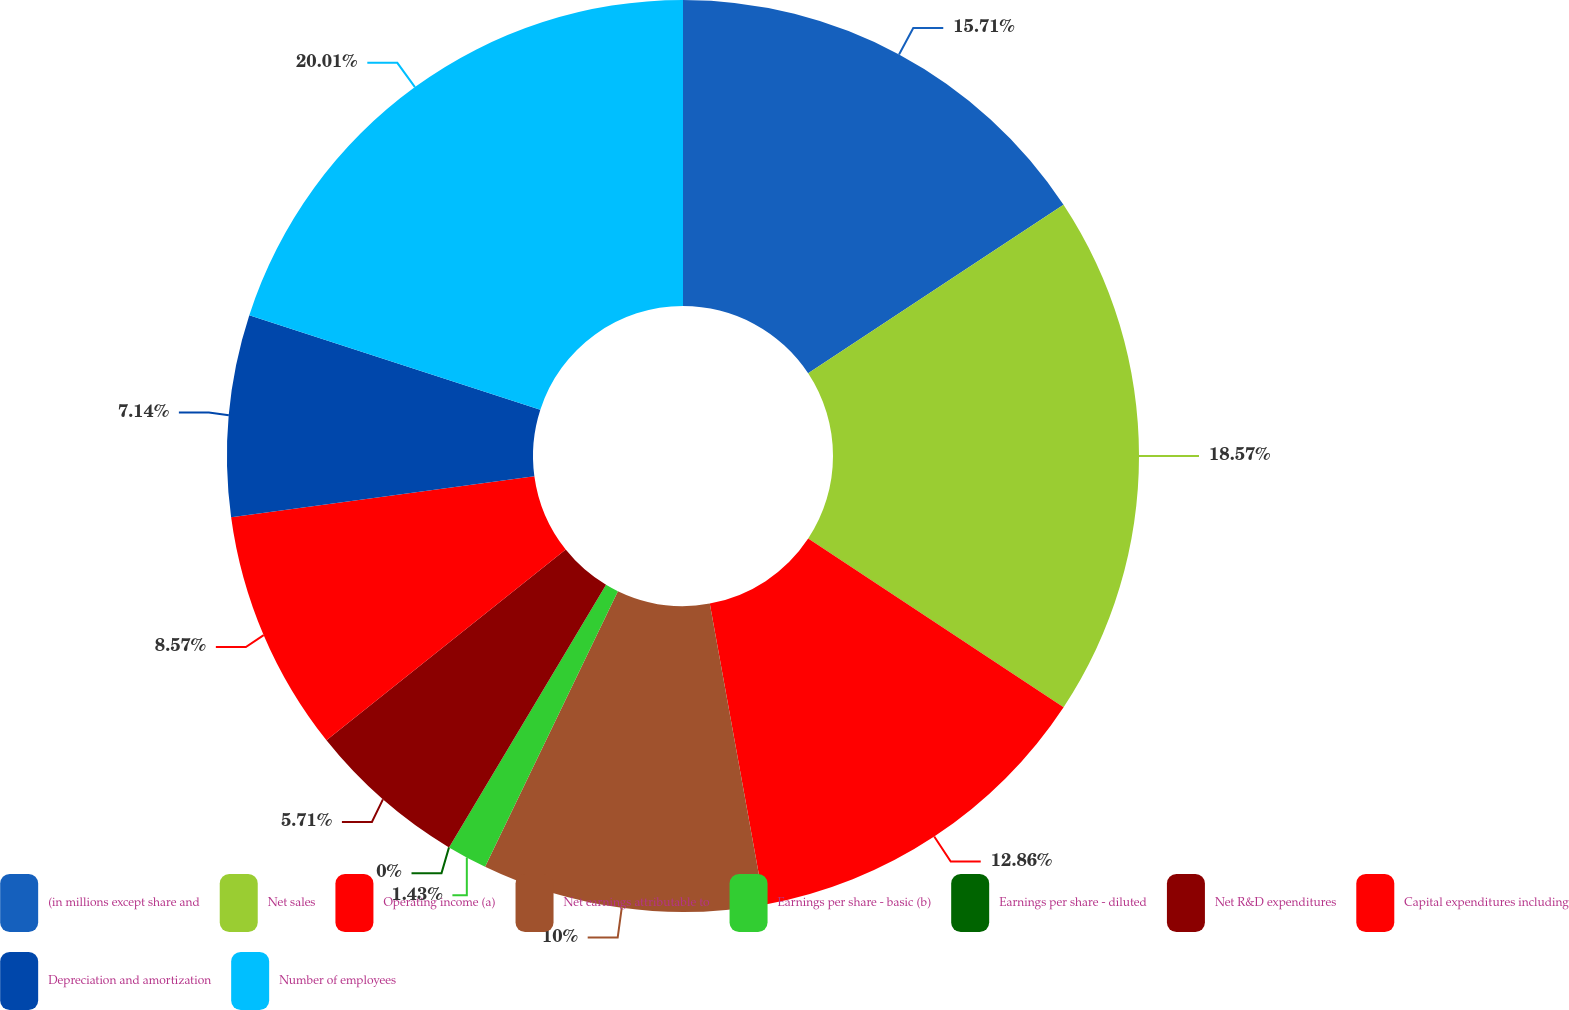<chart> <loc_0><loc_0><loc_500><loc_500><pie_chart><fcel>(in millions except share and<fcel>Net sales<fcel>Operating income (a)<fcel>Net earnings attributable to<fcel>Earnings per share - basic (b)<fcel>Earnings per share - diluted<fcel>Net R&D expenditures<fcel>Capital expenditures including<fcel>Depreciation and amortization<fcel>Number of employees<nl><fcel>15.71%<fcel>18.57%<fcel>12.86%<fcel>10.0%<fcel>1.43%<fcel>0.0%<fcel>5.71%<fcel>8.57%<fcel>7.14%<fcel>20.0%<nl></chart> 